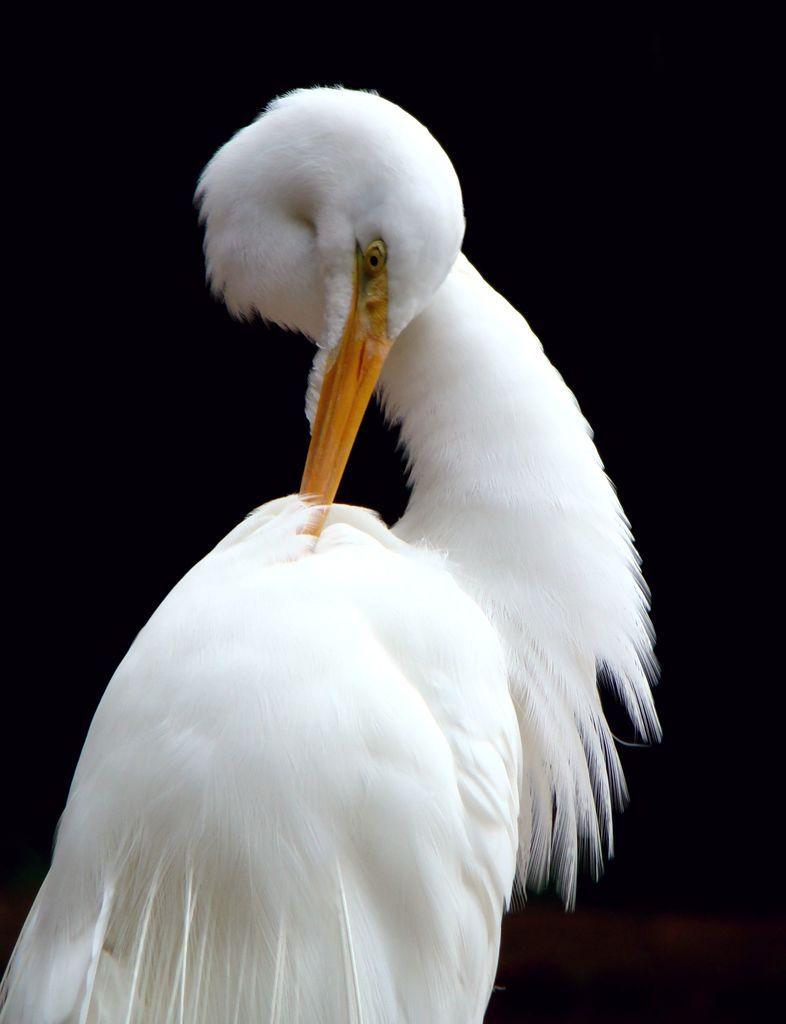Please provide a concise description of this image. In this image we can see a bird with long beak. 